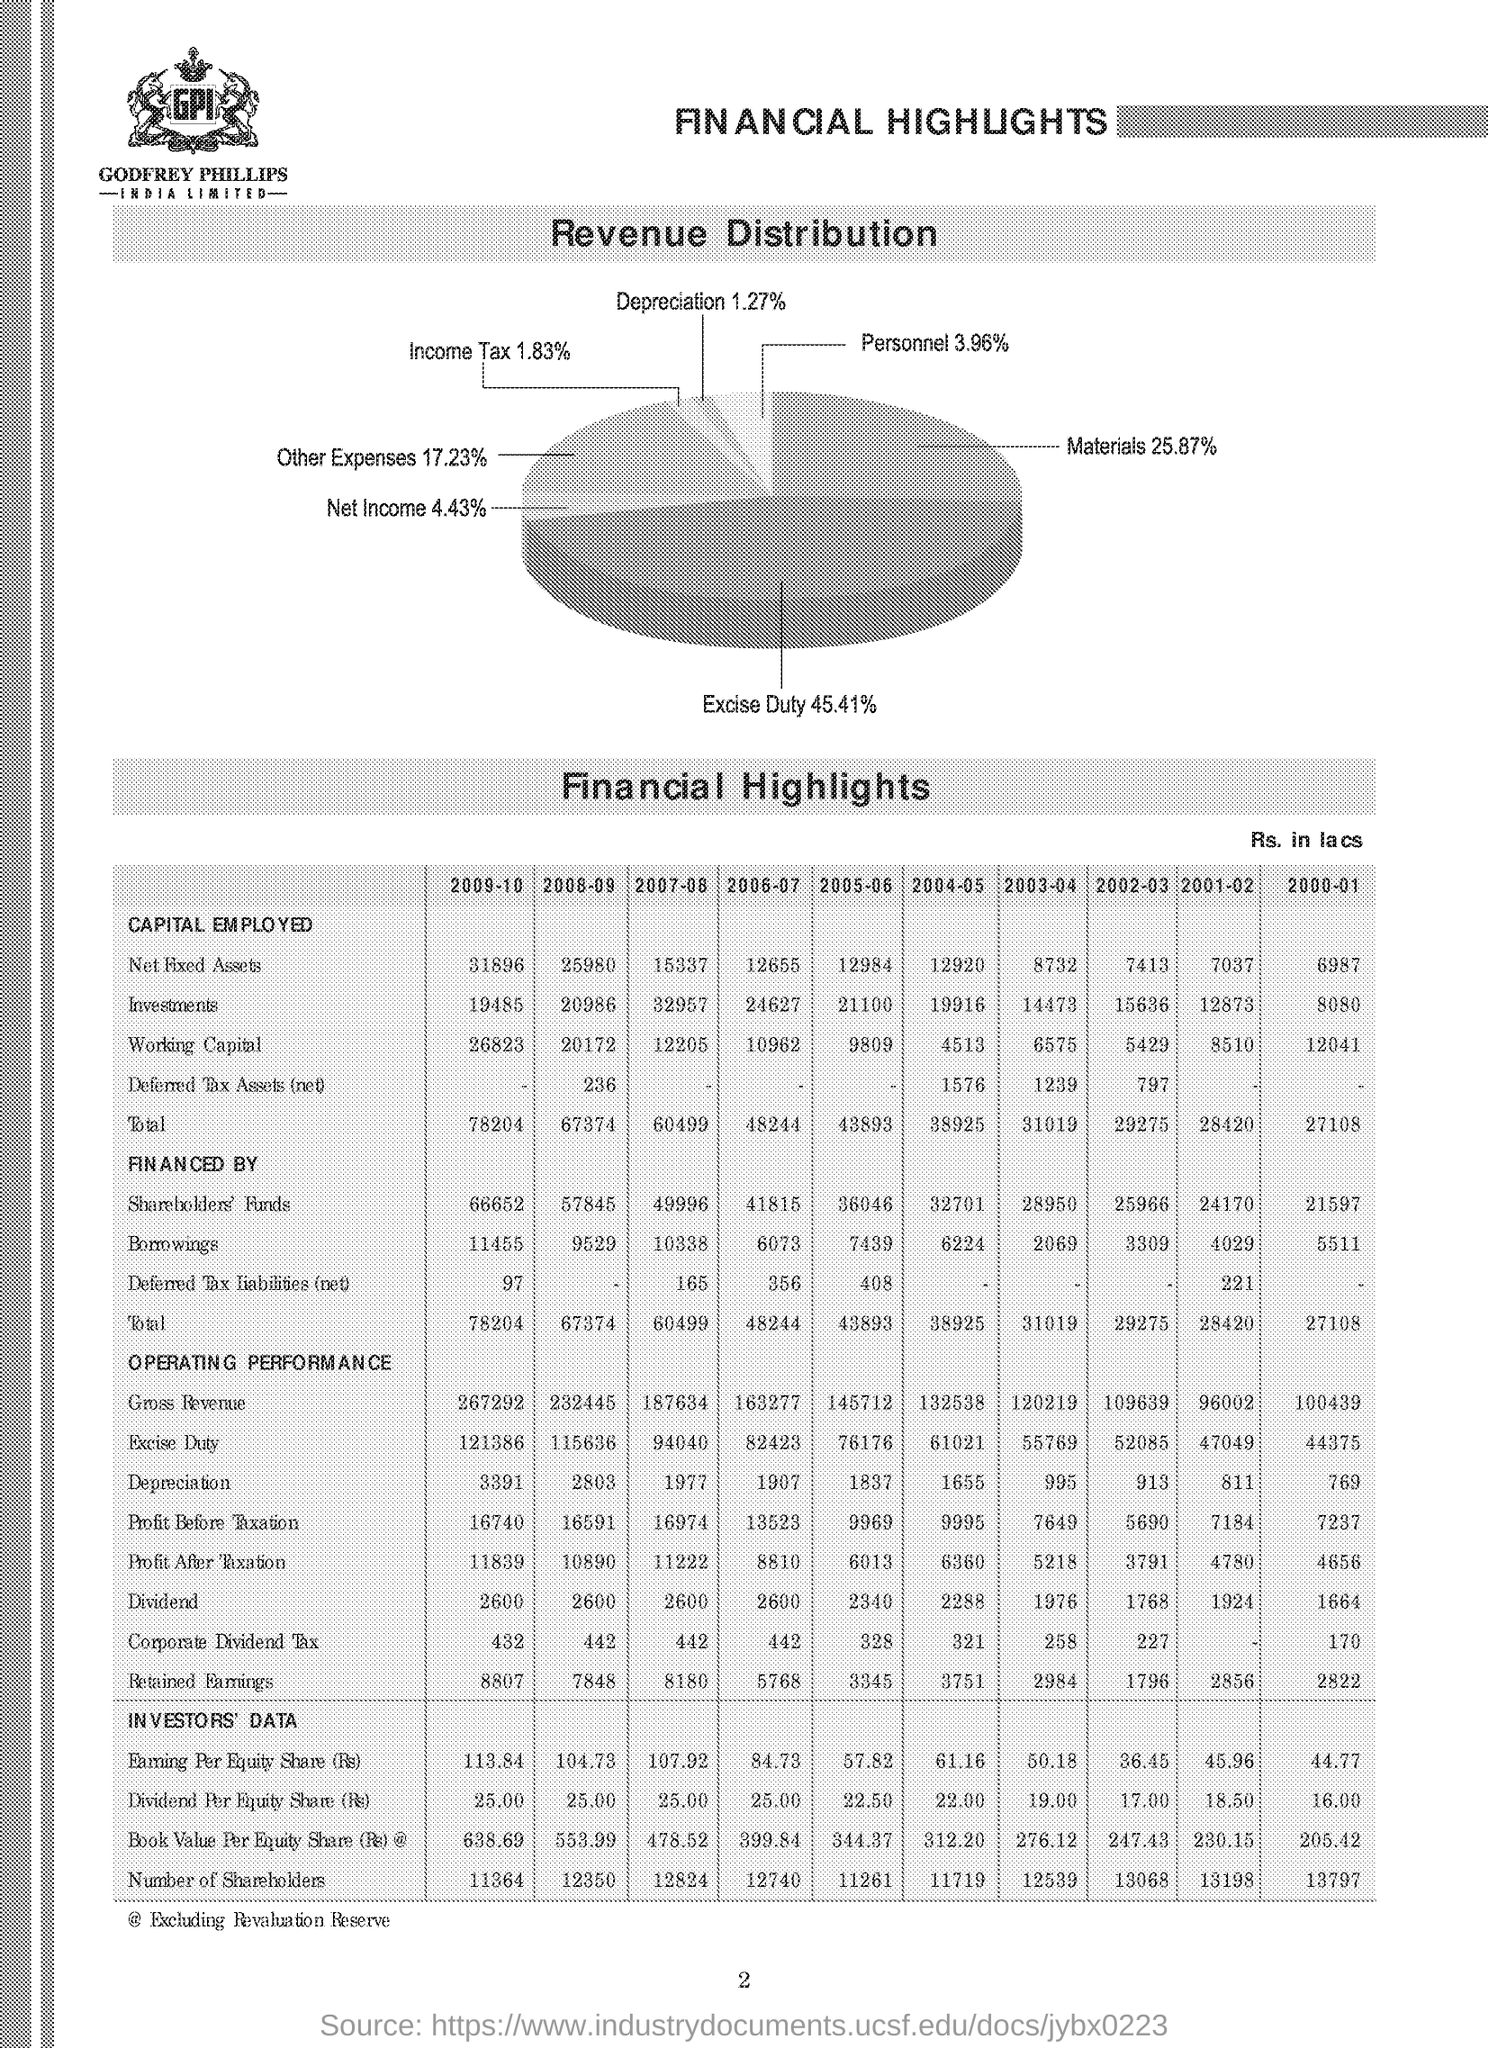How does the Dividend Per Equity Share compare in 2000-01 and 2009-10? The Dividend Per Equity Share was lower in 2000-01 at 15.00 compared to 2009-10 where it increased to 25.00, showing growth in the amount of dividends paid to shareholders over the decade. 